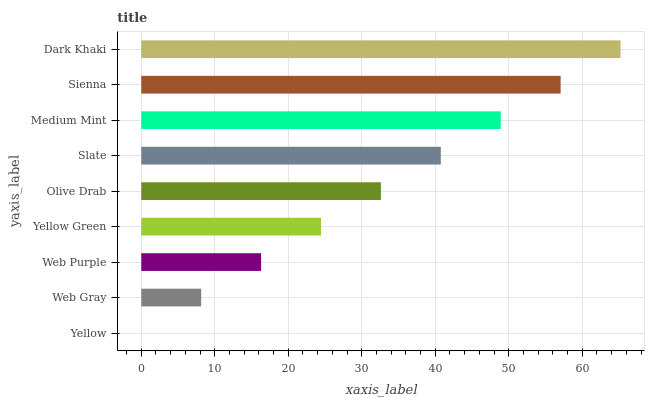Is Yellow the minimum?
Answer yes or no. Yes. Is Dark Khaki the maximum?
Answer yes or no. Yes. Is Web Gray the minimum?
Answer yes or no. No. Is Web Gray the maximum?
Answer yes or no. No. Is Web Gray greater than Yellow?
Answer yes or no. Yes. Is Yellow less than Web Gray?
Answer yes or no. Yes. Is Yellow greater than Web Gray?
Answer yes or no. No. Is Web Gray less than Yellow?
Answer yes or no. No. Is Olive Drab the high median?
Answer yes or no. Yes. Is Olive Drab the low median?
Answer yes or no. Yes. Is Sienna the high median?
Answer yes or no. No. Is Web Purple the low median?
Answer yes or no. No. 